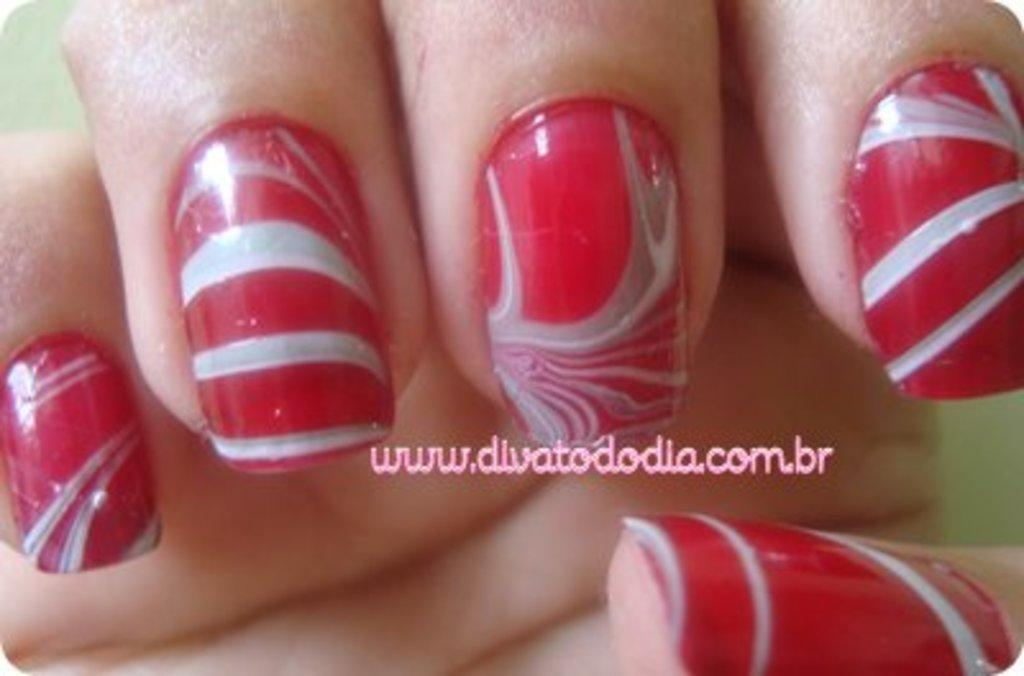<image>
Relay a brief, clear account of the picture shown. A picture of nails with a link to the website www.divatododlia.con.br 